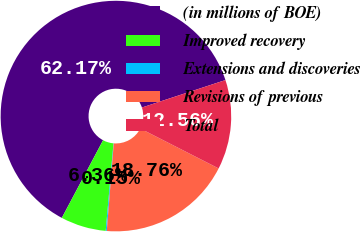Convert chart to OTSL. <chart><loc_0><loc_0><loc_500><loc_500><pie_chart><fcel>(in millions of BOE)<fcel>Improved recovery<fcel>Extensions and discoveries<fcel>Revisions of previous<fcel>Total<nl><fcel>62.17%<fcel>6.36%<fcel>0.15%<fcel>18.76%<fcel>12.56%<nl></chart> 